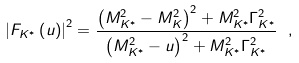Convert formula to latex. <formula><loc_0><loc_0><loc_500><loc_500>\left | F _ { K ^ { * } } \left ( u \right ) \right | ^ { 2 } = \frac { \left ( M _ { K ^ { * } } ^ { 2 } - M _ { K } ^ { 2 } \right ) ^ { 2 } + M _ { K ^ { * } } ^ { 2 } \Gamma _ { K ^ { * } } ^ { 2 } } { \left ( M _ { K ^ { * } } ^ { 2 } - u \right ) ^ { 2 } + M _ { K ^ { * } } ^ { 2 } \Gamma _ { K ^ { * } } ^ { 2 } } \ ,</formula> 